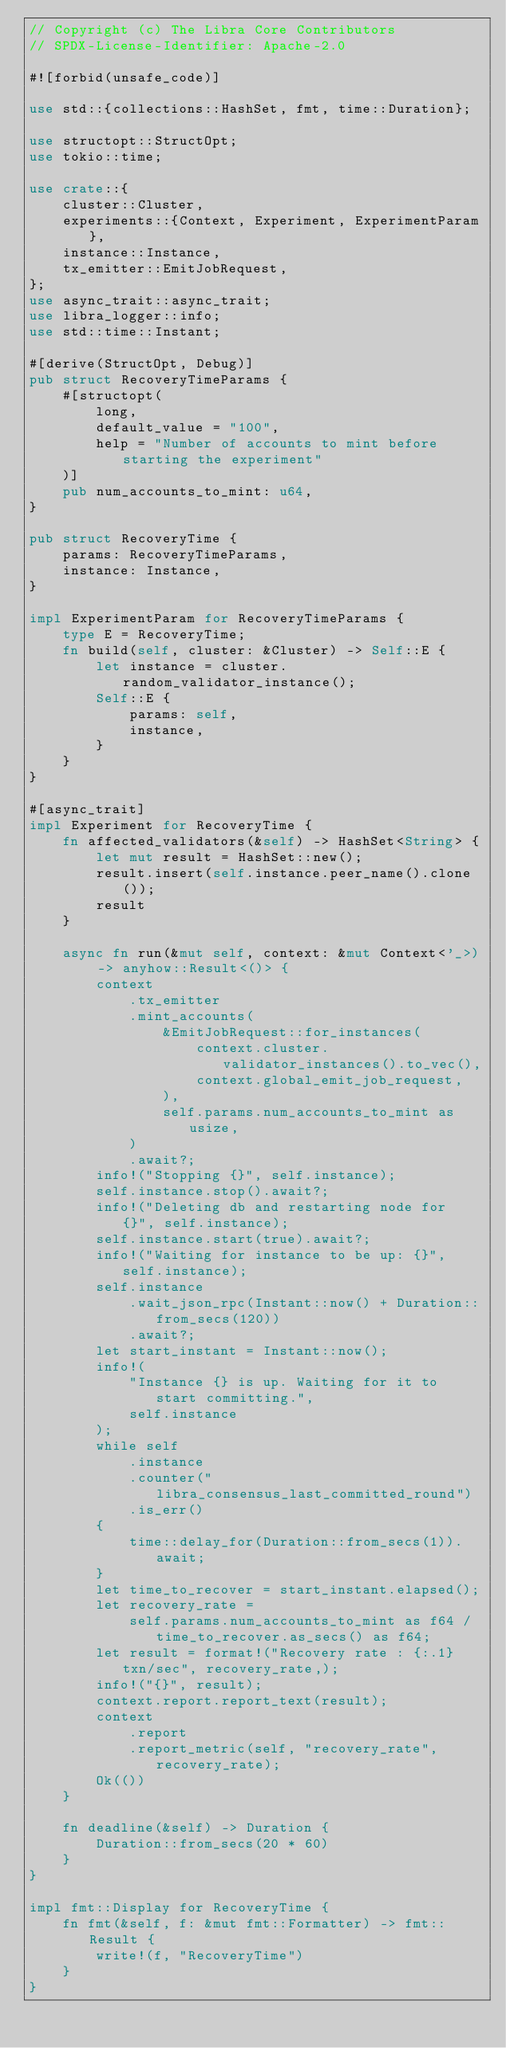<code> <loc_0><loc_0><loc_500><loc_500><_Rust_>// Copyright (c) The Libra Core Contributors
// SPDX-License-Identifier: Apache-2.0

#![forbid(unsafe_code)]

use std::{collections::HashSet, fmt, time::Duration};

use structopt::StructOpt;
use tokio::time;

use crate::{
    cluster::Cluster,
    experiments::{Context, Experiment, ExperimentParam},
    instance::Instance,
    tx_emitter::EmitJobRequest,
};
use async_trait::async_trait;
use libra_logger::info;
use std::time::Instant;

#[derive(StructOpt, Debug)]
pub struct RecoveryTimeParams {
    #[structopt(
        long,
        default_value = "100",
        help = "Number of accounts to mint before starting the experiment"
    )]
    pub num_accounts_to_mint: u64,
}

pub struct RecoveryTime {
    params: RecoveryTimeParams,
    instance: Instance,
}

impl ExperimentParam for RecoveryTimeParams {
    type E = RecoveryTime;
    fn build(self, cluster: &Cluster) -> Self::E {
        let instance = cluster.random_validator_instance();
        Self::E {
            params: self,
            instance,
        }
    }
}

#[async_trait]
impl Experiment for RecoveryTime {
    fn affected_validators(&self) -> HashSet<String> {
        let mut result = HashSet::new();
        result.insert(self.instance.peer_name().clone());
        result
    }

    async fn run(&mut self, context: &mut Context<'_>) -> anyhow::Result<()> {
        context
            .tx_emitter
            .mint_accounts(
                &EmitJobRequest::for_instances(
                    context.cluster.validator_instances().to_vec(),
                    context.global_emit_job_request,
                ),
                self.params.num_accounts_to_mint as usize,
            )
            .await?;
        info!("Stopping {}", self.instance);
        self.instance.stop().await?;
        info!("Deleting db and restarting node for {}", self.instance);
        self.instance.start(true).await?;
        info!("Waiting for instance to be up: {}", self.instance);
        self.instance
            .wait_json_rpc(Instant::now() + Duration::from_secs(120))
            .await?;
        let start_instant = Instant::now();
        info!(
            "Instance {} is up. Waiting for it to start committing.",
            self.instance
        );
        while self
            .instance
            .counter("libra_consensus_last_committed_round")
            .is_err()
        {
            time::delay_for(Duration::from_secs(1)).await;
        }
        let time_to_recover = start_instant.elapsed();
        let recovery_rate =
            self.params.num_accounts_to_mint as f64 / time_to_recover.as_secs() as f64;
        let result = format!("Recovery rate : {:.1} txn/sec", recovery_rate,);
        info!("{}", result);
        context.report.report_text(result);
        context
            .report
            .report_metric(self, "recovery_rate", recovery_rate);
        Ok(())
    }

    fn deadline(&self) -> Duration {
        Duration::from_secs(20 * 60)
    }
}

impl fmt::Display for RecoveryTime {
    fn fmt(&self, f: &mut fmt::Formatter) -> fmt::Result {
        write!(f, "RecoveryTime")
    }
}
</code> 